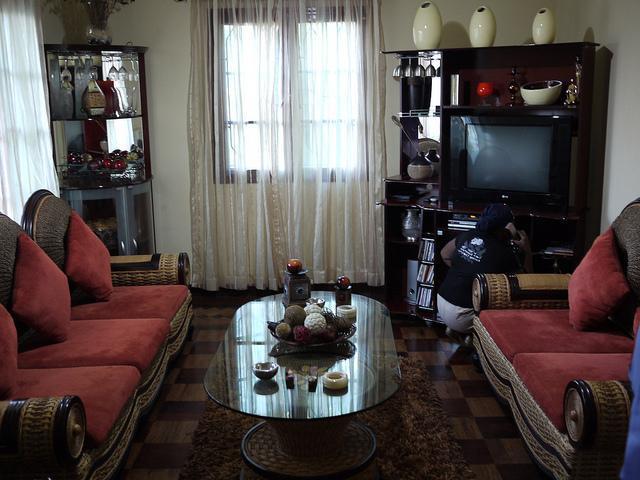How many vases are on top of the entertainment center?
Give a very brief answer. 3. How many couches are there?
Give a very brief answer. 2. 